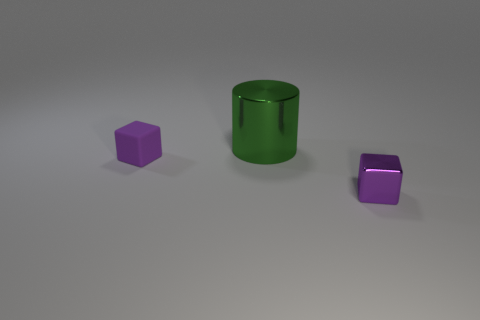What is the largest object in the image? The largest object in this image is the green cylinder located at the center.  Can you tell something about the lighting in the scene? The lighting in the scene appears to be coming from above, as indicated by the soft shadows directly underneath each object, suggesting an ambient or diffused light source. 